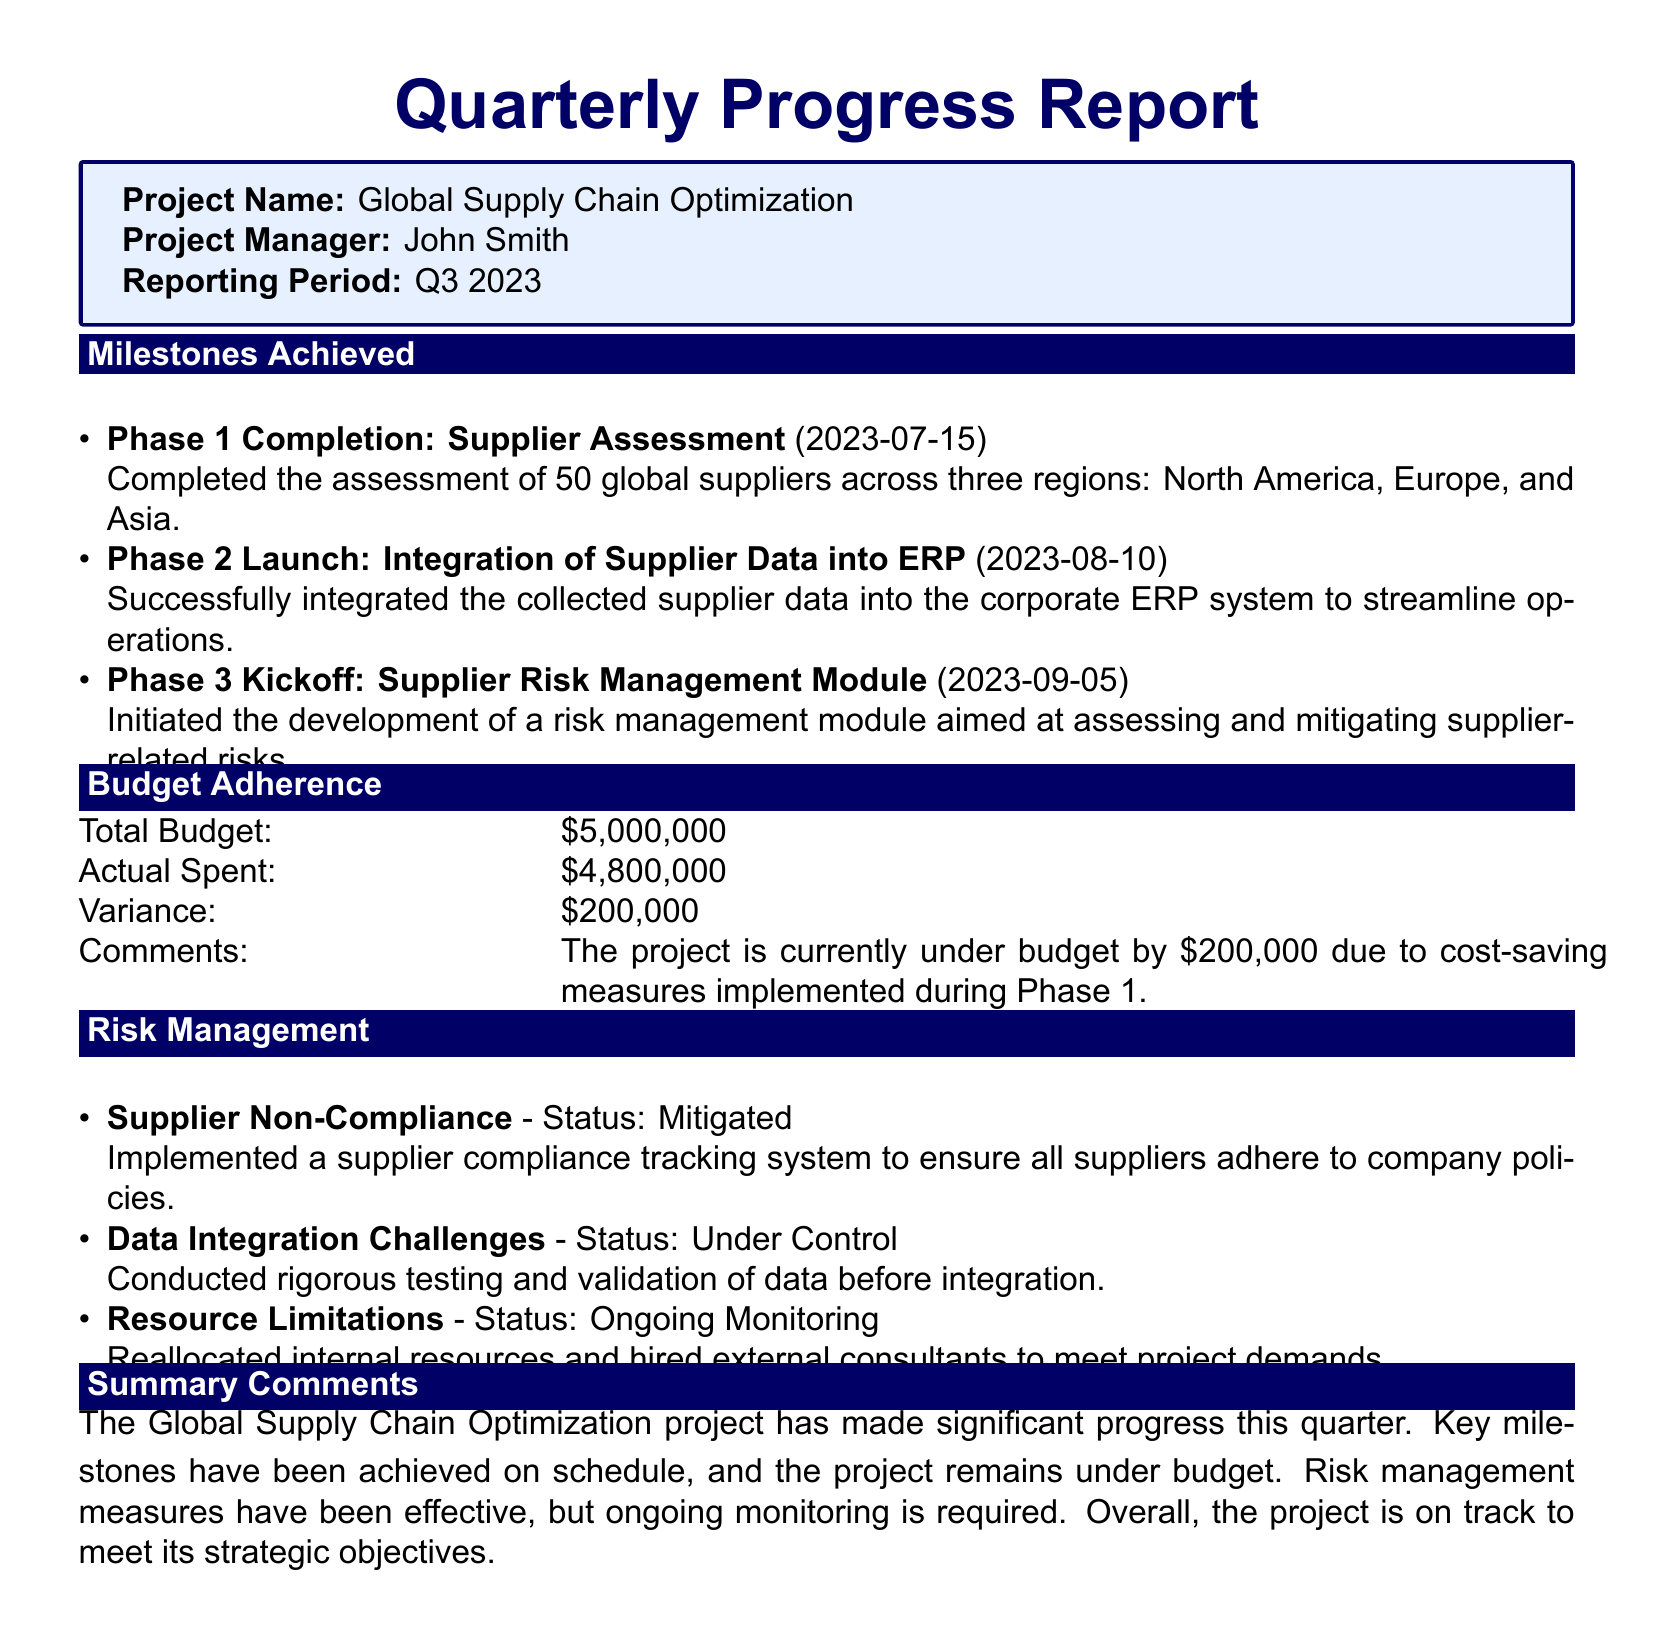What is the project name? The project name is clearly stated in the introduction section of the document.
Answer: Global Supply Chain Optimization Who is the project manager? The project manager's name is listed right below the project name in the document.
Answer: John Smith What is the total budget? The total budget for the project is specified in the budget adherence section of the document.
Answer: $5,000,000 What was the actual amount spent? The actual amount spent is provided in the budget adherence section.
Answer: $4,800,000 What is the variance in the budget? The variance is calculated as the difference between the total budget and the actual spent amount.
Answer: $200,000 On what date was Phase 1 completed? The completion date for Phase 1 is mentioned under milestones achieved.
Answer: 2023-07-15 What status is assigned to supplier non-compliance? The status for supplier non-compliance is specified in the risk management section.
Answer: Mitigated Which phase was launched on August 10, 2023? The launch of this phase is noted in the milestones achieved section.
Answer: Phase 2 What are the ongoing measures for resource limitations? This is mentioned in the risk management section, addressing how the project is handling resource issues.
Answer: Ongoing Monitoring Is the project under budget or over budget? The budget adherence section provides information about the project's financial status.
Answer: Under budget 